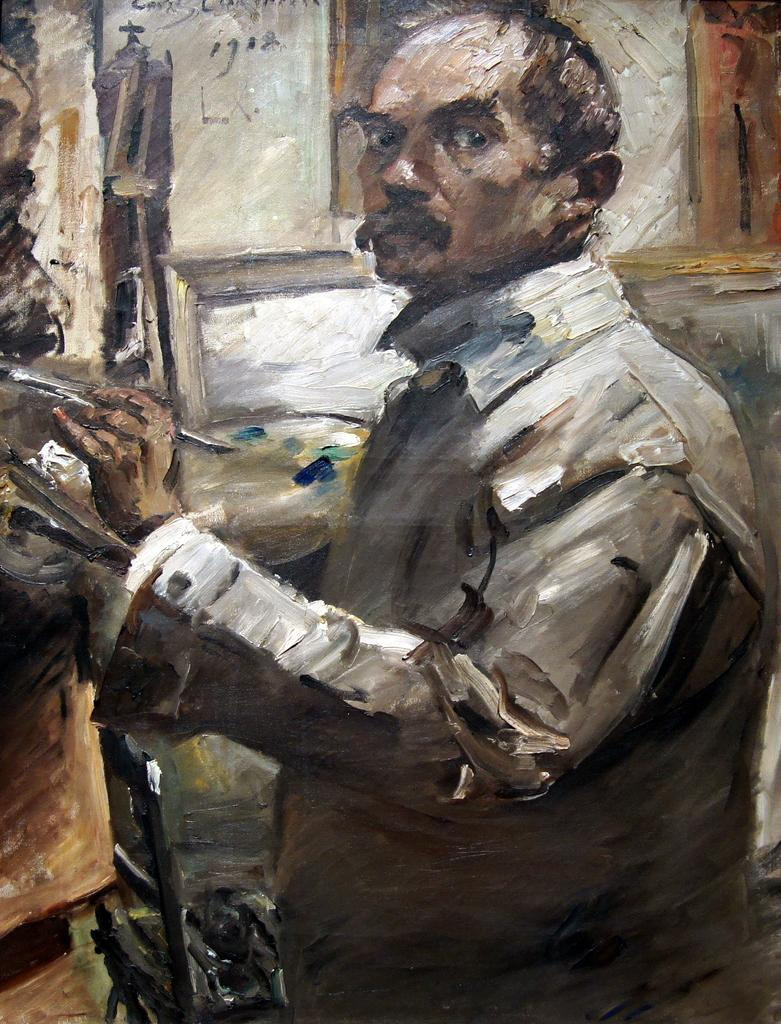What is the main subject of the image? There is a painting in the image. What is happening in the painting? The painting depicts a person holding an object. Can you describe the background of the painting? The background of the painting is not clear. What type of record can be seen on the table in the image? There is no table or record present in the image; it only features a painting. How many dimes are visible on the person's hand in the painting? There is no mention of dimes in the painting; the person is holding an unspecified object. 